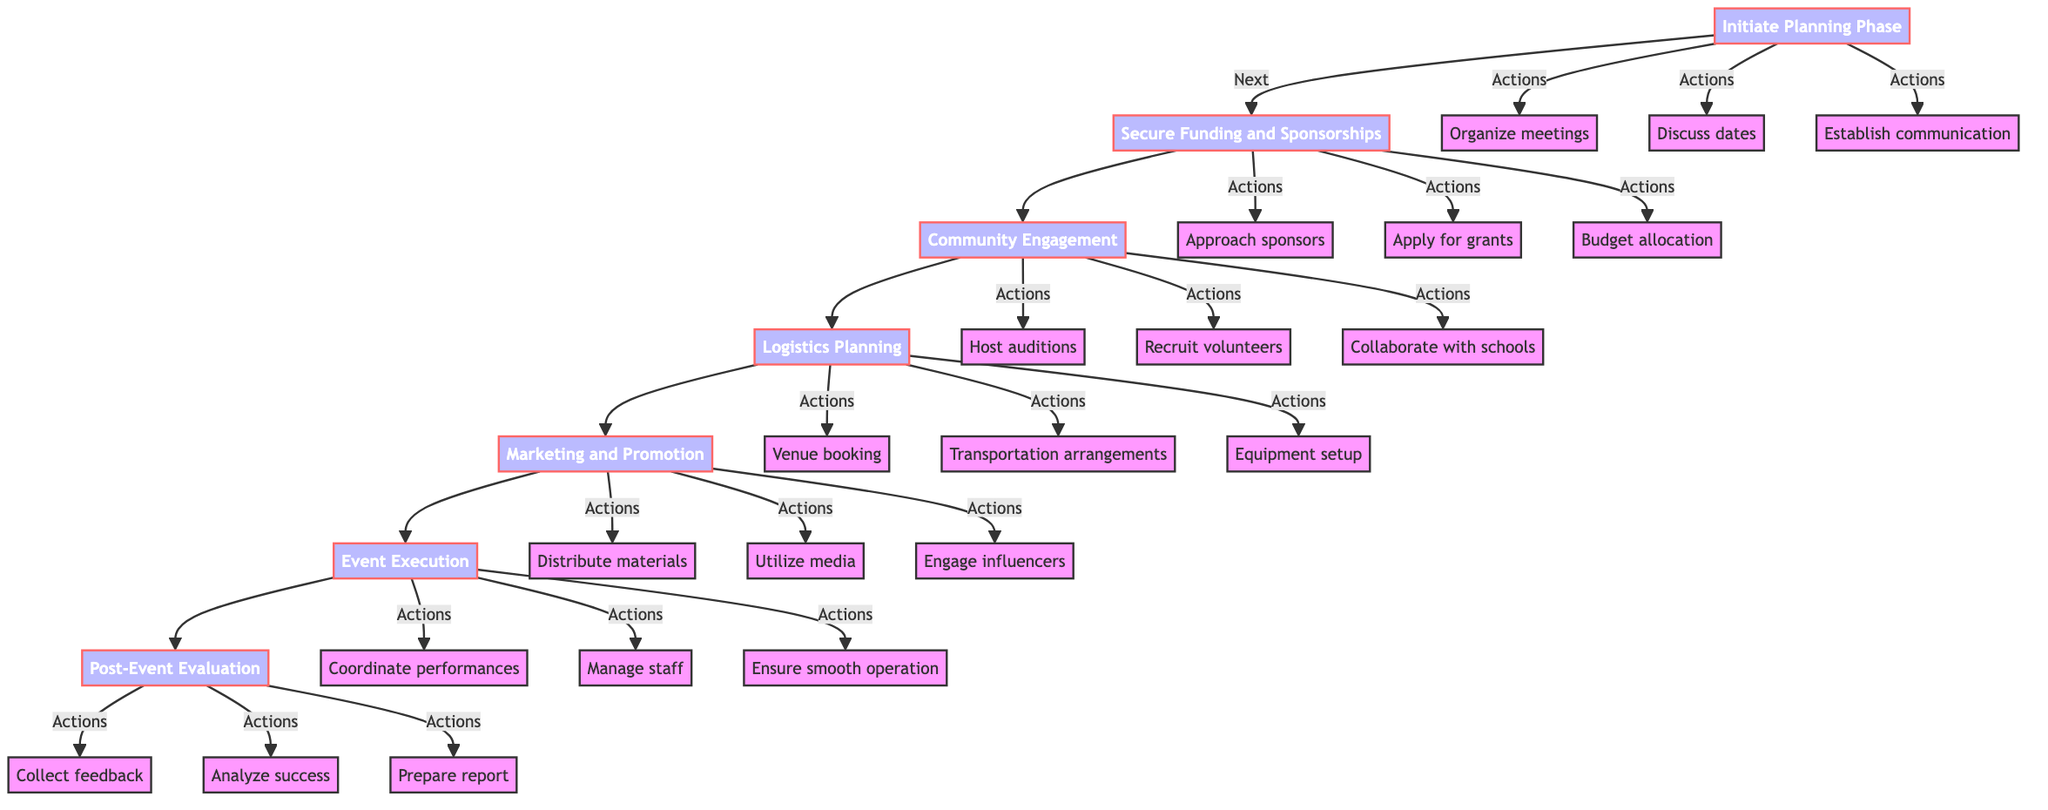What is the first phase of the coordination effort? The flow chart begins with the "Initiate Planning Phase," which is the first node listed.
Answer: Initiate Planning Phase How many main phases are there in total? The diagram includes seven main phases from "Initiate Planning Phase" to "Post-Event Evaluation," which can be counted directly.
Answer: Seven What action is included in the "Secure Funding and Sponsorships" phase? One of the actions listed under this phase is "Identify and approach potential sponsors," showing the tasks that need to be completed in this phase.
Answer: Identify and approach potential sponsors What follows after "Logistics Planning"? The next phase that follows "Logistics Planning" is "Marketing and Promotion," according to the directional arrows in the flowchart.
Answer: Marketing and Promotion Which phase involves engaging local musicians? The "Community Engagement" phase explicitly mentions engaging local musicians as one of its main focuses.
Answer: Community Engagement What is one of the actions listed under the "Event Execution" phase? The action "Coordinate schedules and performances" is one of the key tasks listed under the "Event Execution" phase, highlighting responsibilities during the festival.
Answer: Coordinate schedules and performances How does the "Post-Event Evaluation" phase relate to the previous phase? The "Post-Event Evaluation" phase comes after "Event Execution," indicating that evaluation occurs after the festival has been implemented.
Answer: Comes after Event Execution What types of materials are to be used in the "Marketing and Promotion" phase? The phase mentions using "promotional materials," which indicates the type of content to be designed and distributed for marketing efforts.
Answer: Promotional materials What is the last action in the flowchart? The last action listed is "Prepare a report for sponsors and partners," part of the "Post-Event Evaluation" phase, indicating final steps after the event.
Answer: Prepare a report for sponsors and partners 